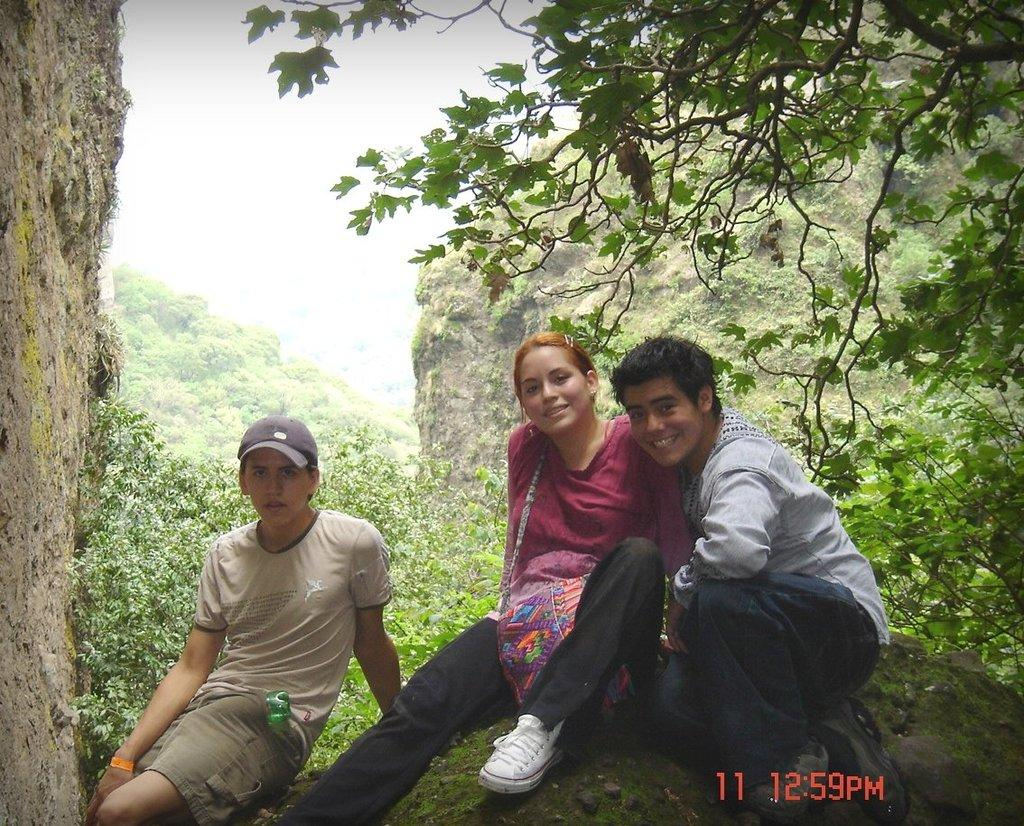How many people are present in the image? There are three people in the image. What can be observed about the clothing of the people in the image? The people are wearing different color dresses. Can you describe any accessories worn by the people in the image? One person is wearing a cap. What can be seen in the background of the image? There are trees and the sky visible in the background of the image. What type of medical equipment can be seen in the image? There is no medical equipment present in the image. What type of picture is being taken in the image? There is no indication in the image that a picture is being taken. 